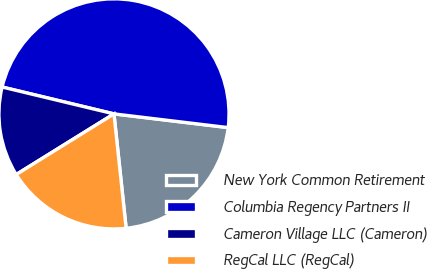<chart> <loc_0><loc_0><loc_500><loc_500><pie_chart><fcel>New York Common Retirement<fcel>Columbia Regency Partners II<fcel>Cameron Village LLC (Cameron)<fcel>RegCal LLC (RegCal)<nl><fcel>21.41%<fcel>48.15%<fcel>12.59%<fcel>17.85%<nl></chart> 